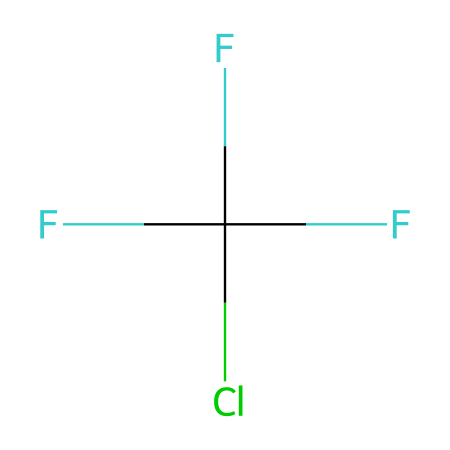What is the name of this chemical? The chemical represented by the SMILES is dichlorofluoromethane or CFC-12. This name is derived from its structure, which contains chlorine and fluorine atoms in its composition, as well as a methyl group.
Answer: dichlorofluoromethane How many carbon atoms are present in this chemical? By examining the SMILES structure, we see that there is one carbon atom connected to three fluorine atoms and one chlorine atom. The presence of a single 'C' in the SMILES indicates that there is one carbon atom.
Answer: one What type of bonds are present in this chemical? The SMILES notation indicates that the carbon is bonded to other halogens. Since it has single bonds connecting the carbon to chlorine and fluorine, the bonds are classified as single bonds (sigma bonds).
Answer: single bonds How many fluorine atoms are in this molecule? In the SMILES, the notation 'F' appears three times, meaning there are three fluorine atoms attached to the carbon. Thus, we can count the number of 'F' in the representation.
Answer: three Why are CFCs considered harmful to the environment? The structure includes chlorine atoms, which play a significant role in breaking down ozone in the stratosphere when CFCs are released into the atmosphere. This degradation of ozone leads to increased UV radiation reaching the Earth's surface, hence causing environmental harm.
Answer: ozone depletion What is one significant property of this chemical? This chemical is known to be a refrigerant and has a low boiling point, allowing for its use in cooling applications. One significant property is its efficiency in absorbing heat.
Answer: low boiling point What action was taken against the use of CFCs? The Montreal Protocol was established to phase out substances that deplete the ozone layer, including CFCs, due to their environmental impact. This international treaty aimed to protect the ozone layer by reducing the production and consumption of these harmful chemicals.
Answer: Montreal Protocol 